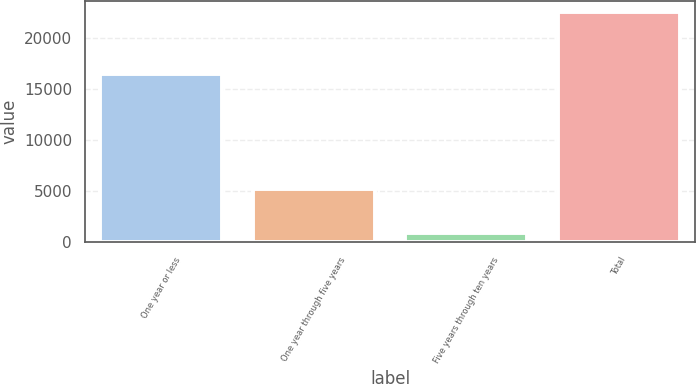Convert chart. <chart><loc_0><loc_0><loc_500><loc_500><bar_chart><fcel>One year or less<fcel>One year through five years<fcel>Five years through ten years<fcel>Total<nl><fcel>16532<fcel>5177<fcel>846<fcel>22555<nl></chart> 